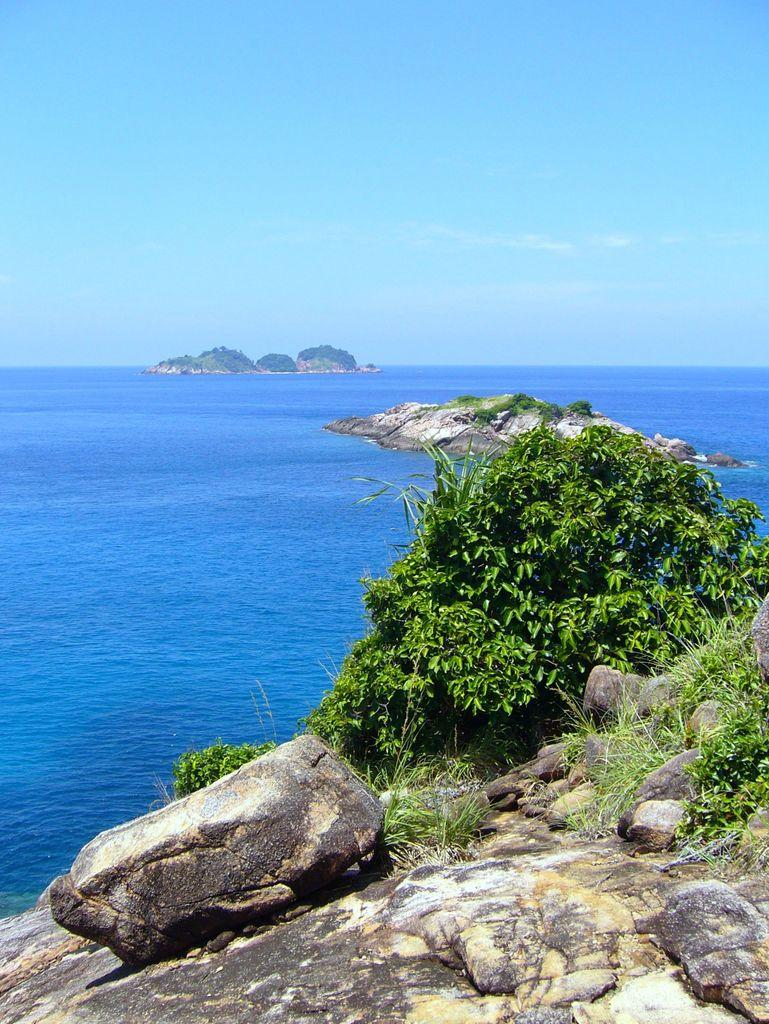What type of natural elements can be seen in the image? There are rocks, trees, and grass visible in the image. What can be seen in the background of the image? There is water and the sky visible in the background of the image. How many different types of natural elements are present in the image? There are three different types of natural elements present in the image: rocks, trees, and grass. What is the price of the chalk in the image? There is no chalk present in the image, so it is not possible to determine its price. Can you tell me how many pets are visible in the image? There are no pets visible in the image; it features rocks, trees, grass, water, and the sky. 